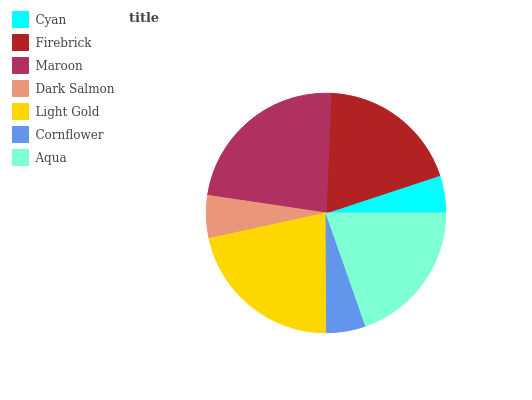Is Cyan the minimum?
Answer yes or no. Yes. Is Maroon the maximum?
Answer yes or no. Yes. Is Firebrick the minimum?
Answer yes or no. No. Is Firebrick the maximum?
Answer yes or no. No. Is Firebrick greater than Cyan?
Answer yes or no. Yes. Is Cyan less than Firebrick?
Answer yes or no. Yes. Is Cyan greater than Firebrick?
Answer yes or no. No. Is Firebrick less than Cyan?
Answer yes or no. No. Is Firebrick the high median?
Answer yes or no. Yes. Is Firebrick the low median?
Answer yes or no. Yes. Is Cornflower the high median?
Answer yes or no. No. Is Cornflower the low median?
Answer yes or no. No. 